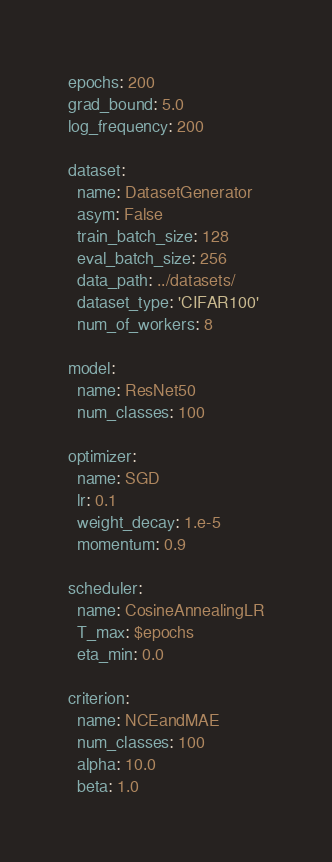<code> <loc_0><loc_0><loc_500><loc_500><_YAML_>epochs: 200
grad_bound: 5.0
log_frequency: 200

dataset:
  name: DatasetGenerator
  asym: False
  train_batch_size: 128
  eval_batch_size: 256
  data_path: ../datasets/
  dataset_type: 'CIFAR100'
  num_of_workers: 8

model:
  name: ResNet50
  num_classes: 100

optimizer:
  name: SGD
  lr: 0.1
  weight_decay: 1.e-5
  momentum: 0.9

scheduler:
  name: CosineAnnealingLR
  T_max: $epochs
  eta_min: 0.0

criterion:
  name: NCEandMAE
  num_classes: 100
  alpha: 10.0
  beta: 1.0
</code> 